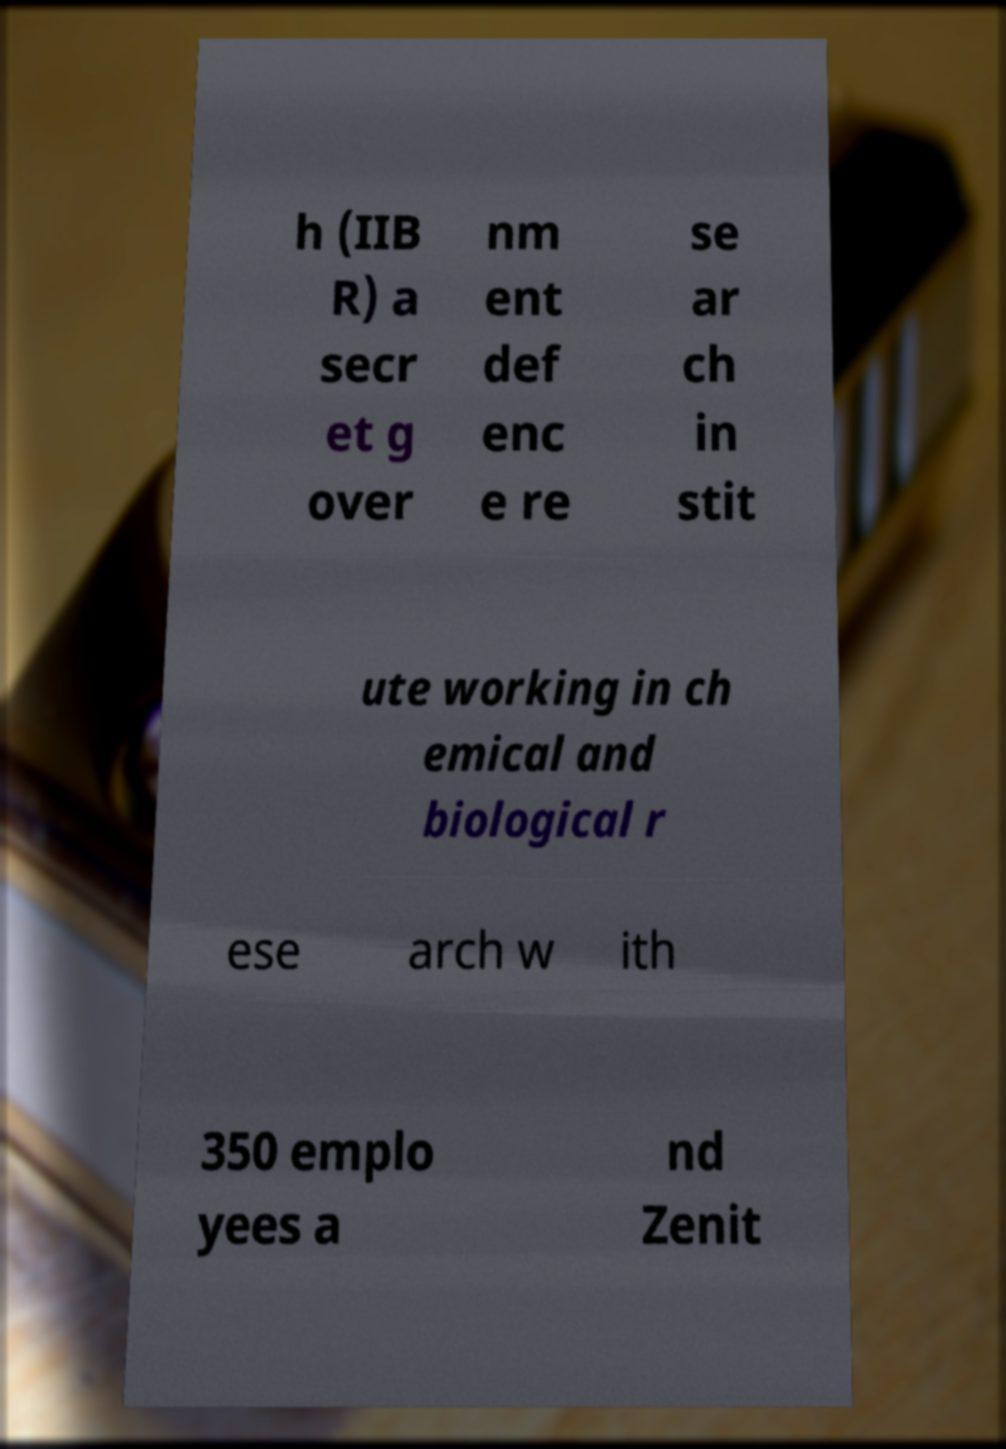What messages or text are displayed in this image? I need them in a readable, typed format. h (IIB R) a secr et g over nm ent def enc e re se ar ch in stit ute working in ch emical and biological r ese arch w ith 350 emplo yees a nd Zenit 